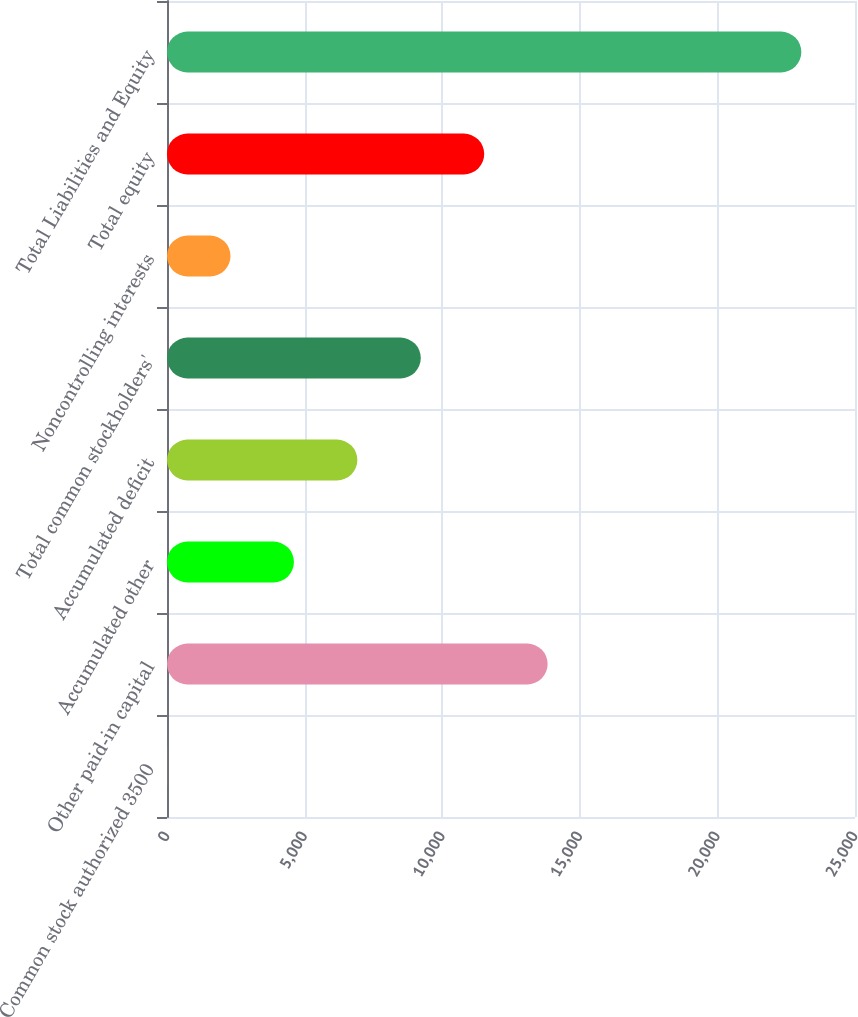<chart> <loc_0><loc_0><loc_500><loc_500><bar_chart><fcel>Common stock authorized 3500<fcel>Other paid-in capital<fcel>Accumulated other<fcel>Accumulated deficit<fcel>Total common stockholders'<fcel>Noncontrolling interests<fcel>Total equity<fcel>Total Liabilities and Equity<nl><fcel>3<fcel>13831.2<fcel>4612.4<fcel>6917.1<fcel>9221.8<fcel>2307.7<fcel>11526.5<fcel>23050<nl></chart> 